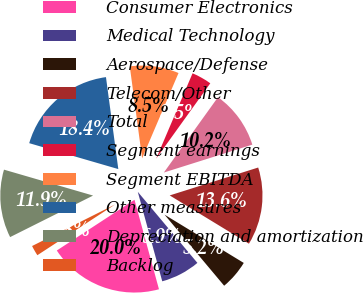<chart> <loc_0><loc_0><loc_500><loc_500><pie_chart><fcel>Consumer Electronics<fcel>Medical Technology<fcel>Aerospace/Defense<fcel>Telecom/Other<fcel>Total<fcel>Segment earnings<fcel>Segment EBITDA<fcel>Other measures<fcel>Depreciation and amortization<fcel>Backlog<nl><fcel>20.04%<fcel>6.86%<fcel>5.18%<fcel>13.57%<fcel>10.22%<fcel>3.5%<fcel>8.54%<fcel>18.37%<fcel>11.89%<fcel>1.82%<nl></chart> 